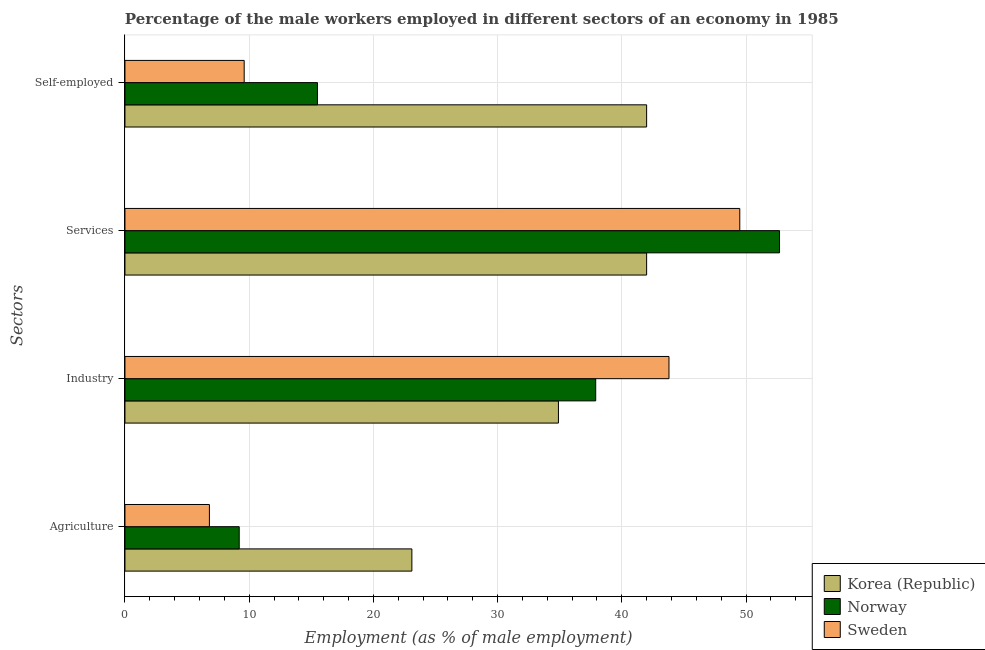What is the label of the 3rd group of bars from the top?
Provide a succinct answer. Industry. What is the percentage of male workers in agriculture in Norway?
Keep it short and to the point. 9.2. Across all countries, what is the maximum percentage of male workers in industry?
Give a very brief answer. 43.8. In which country was the percentage of self employed male workers maximum?
Provide a succinct answer. Korea (Republic). In which country was the percentage of male workers in industry minimum?
Your response must be concise. Korea (Republic). What is the total percentage of male workers in agriculture in the graph?
Your response must be concise. 39.1. What is the difference between the percentage of male workers in agriculture in Sweden and the percentage of male workers in services in Norway?
Ensure brevity in your answer.  -45.9. What is the average percentage of self employed male workers per country?
Give a very brief answer. 22.37. What is the difference between the percentage of male workers in agriculture and percentage of male workers in services in Korea (Republic)?
Offer a terse response. -18.9. In how many countries, is the percentage of self employed male workers greater than 48 %?
Offer a terse response. 0. What is the ratio of the percentage of self employed male workers in Korea (Republic) to that in Sweden?
Provide a short and direct response. 4.37. Is the percentage of male workers in industry in Korea (Republic) less than that in Norway?
Offer a terse response. Yes. Is the difference between the percentage of male workers in services in Korea (Republic) and Norway greater than the difference between the percentage of self employed male workers in Korea (Republic) and Norway?
Provide a succinct answer. No. What is the difference between the highest and the second highest percentage of self employed male workers?
Your response must be concise. 26.5. What is the difference between the highest and the lowest percentage of male workers in industry?
Keep it short and to the point. 8.9. What does the 3rd bar from the top in Self-employed represents?
Provide a short and direct response. Korea (Republic). Is it the case that in every country, the sum of the percentage of male workers in agriculture and percentage of male workers in industry is greater than the percentage of male workers in services?
Keep it short and to the point. No. Are all the bars in the graph horizontal?
Your answer should be compact. Yes. How many countries are there in the graph?
Your answer should be very brief. 3. What is the difference between two consecutive major ticks on the X-axis?
Provide a short and direct response. 10. Are the values on the major ticks of X-axis written in scientific E-notation?
Your answer should be very brief. No. Does the graph contain any zero values?
Give a very brief answer. No. Does the graph contain grids?
Make the answer very short. Yes. How are the legend labels stacked?
Make the answer very short. Vertical. What is the title of the graph?
Give a very brief answer. Percentage of the male workers employed in different sectors of an economy in 1985. What is the label or title of the X-axis?
Give a very brief answer. Employment (as % of male employment). What is the label or title of the Y-axis?
Provide a succinct answer. Sectors. What is the Employment (as % of male employment) of Korea (Republic) in Agriculture?
Make the answer very short. 23.1. What is the Employment (as % of male employment) of Norway in Agriculture?
Your answer should be very brief. 9.2. What is the Employment (as % of male employment) of Sweden in Agriculture?
Your answer should be compact. 6.8. What is the Employment (as % of male employment) of Korea (Republic) in Industry?
Your response must be concise. 34.9. What is the Employment (as % of male employment) in Norway in Industry?
Make the answer very short. 37.9. What is the Employment (as % of male employment) of Sweden in Industry?
Provide a succinct answer. 43.8. What is the Employment (as % of male employment) of Korea (Republic) in Services?
Offer a terse response. 42. What is the Employment (as % of male employment) of Norway in Services?
Provide a succinct answer. 52.7. What is the Employment (as % of male employment) of Sweden in Services?
Provide a short and direct response. 49.5. What is the Employment (as % of male employment) of Korea (Republic) in Self-employed?
Your answer should be very brief. 42. What is the Employment (as % of male employment) of Sweden in Self-employed?
Offer a very short reply. 9.6. Across all Sectors, what is the maximum Employment (as % of male employment) of Norway?
Your answer should be very brief. 52.7. Across all Sectors, what is the maximum Employment (as % of male employment) of Sweden?
Provide a short and direct response. 49.5. Across all Sectors, what is the minimum Employment (as % of male employment) of Korea (Republic)?
Your answer should be very brief. 23.1. Across all Sectors, what is the minimum Employment (as % of male employment) of Norway?
Give a very brief answer. 9.2. Across all Sectors, what is the minimum Employment (as % of male employment) in Sweden?
Your answer should be compact. 6.8. What is the total Employment (as % of male employment) of Korea (Republic) in the graph?
Offer a very short reply. 142. What is the total Employment (as % of male employment) in Norway in the graph?
Provide a short and direct response. 115.3. What is the total Employment (as % of male employment) of Sweden in the graph?
Your answer should be compact. 109.7. What is the difference between the Employment (as % of male employment) in Korea (Republic) in Agriculture and that in Industry?
Provide a succinct answer. -11.8. What is the difference between the Employment (as % of male employment) of Norway in Agriculture and that in Industry?
Your answer should be compact. -28.7. What is the difference between the Employment (as % of male employment) of Sweden in Agriculture and that in Industry?
Provide a short and direct response. -37. What is the difference between the Employment (as % of male employment) of Korea (Republic) in Agriculture and that in Services?
Provide a succinct answer. -18.9. What is the difference between the Employment (as % of male employment) of Norway in Agriculture and that in Services?
Your answer should be compact. -43.5. What is the difference between the Employment (as % of male employment) of Sweden in Agriculture and that in Services?
Your answer should be very brief. -42.7. What is the difference between the Employment (as % of male employment) of Korea (Republic) in Agriculture and that in Self-employed?
Give a very brief answer. -18.9. What is the difference between the Employment (as % of male employment) of Norway in Agriculture and that in Self-employed?
Ensure brevity in your answer.  -6.3. What is the difference between the Employment (as % of male employment) in Sweden in Agriculture and that in Self-employed?
Your answer should be very brief. -2.8. What is the difference between the Employment (as % of male employment) in Norway in Industry and that in Services?
Keep it short and to the point. -14.8. What is the difference between the Employment (as % of male employment) in Korea (Republic) in Industry and that in Self-employed?
Offer a very short reply. -7.1. What is the difference between the Employment (as % of male employment) in Norway in Industry and that in Self-employed?
Ensure brevity in your answer.  22.4. What is the difference between the Employment (as % of male employment) in Sweden in Industry and that in Self-employed?
Ensure brevity in your answer.  34.2. What is the difference between the Employment (as % of male employment) of Korea (Republic) in Services and that in Self-employed?
Offer a very short reply. 0. What is the difference between the Employment (as % of male employment) in Norway in Services and that in Self-employed?
Ensure brevity in your answer.  37.2. What is the difference between the Employment (as % of male employment) of Sweden in Services and that in Self-employed?
Make the answer very short. 39.9. What is the difference between the Employment (as % of male employment) of Korea (Republic) in Agriculture and the Employment (as % of male employment) of Norway in Industry?
Offer a very short reply. -14.8. What is the difference between the Employment (as % of male employment) in Korea (Republic) in Agriculture and the Employment (as % of male employment) in Sweden in Industry?
Give a very brief answer. -20.7. What is the difference between the Employment (as % of male employment) in Norway in Agriculture and the Employment (as % of male employment) in Sweden in Industry?
Give a very brief answer. -34.6. What is the difference between the Employment (as % of male employment) in Korea (Republic) in Agriculture and the Employment (as % of male employment) in Norway in Services?
Your response must be concise. -29.6. What is the difference between the Employment (as % of male employment) of Korea (Republic) in Agriculture and the Employment (as % of male employment) of Sweden in Services?
Offer a very short reply. -26.4. What is the difference between the Employment (as % of male employment) of Norway in Agriculture and the Employment (as % of male employment) of Sweden in Services?
Provide a short and direct response. -40.3. What is the difference between the Employment (as % of male employment) in Korea (Republic) in Agriculture and the Employment (as % of male employment) in Norway in Self-employed?
Give a very brief answer. 7.6. What is the difference between the Employment (as % of male employment) in Korea (Republic) in Agriculture and the Employment (as % of male employment) in Sweden in Self-employed?
Your response must be concise. 13.5. What is the difference between the Employment (as % of male employment) of Norway in Agriculture and the Employment (as % of male employment) of Sweden in Self-employed?
Ensure brevity in your answer.  -0.4. What is the difference between the Employment (as % of male employment) of Korea (Republic) in Industry and the Employment (as % of male employment) of Norway in Services?
Provide a succinct answer. -17.8. What is the difference between the Employment (as % of male employment) in Korea (Republic) in Industry and the Employment (as % of male employment) in Sweden in Services?
Provide a short and direct response. -14.6. What is the difference between the Employment (as % of male employment) of Norway in Industry and the Employment (as % of male employment) of Sweden in Services?
Offer a terse response. -11.6. What is the difference between the Employment (as % of male employment) of Korea (Republic) in Industry and the Employment (as % of male employment) of Norway in Self-employed?
Give a very brief answer. 19.4. What is the difference between the Employment (as % of male employment) of Korea (Republic) in Industry and the Employment (as % of male employment) of Sweden in Self-employed?
Your response must be concise. 25.3. What is the difference between the Employment (as % of male employment) in Norway in Industry and the Employment (as % of male employment) in Sweden in Self-employed?
Your answer should be compact. 28.3. What is the difference between the Employment (as % of male employment) of Korea (Republic) in Services and the Employment (as % of male employment) of Norway in Self-employed?
Give a very brief answer. 26.5. What is the difference between the Employment (as % of male employment) in Korea (Republic) in Services and the Employment (as % of male employment) in Sweden in Self-employed?
Provide a succinct answer. 32.4. What is the difference between the Employment (as % of male employment) of Norway in Services and the Employment (as % of male employment) of Sweden in Self-employed?
Your response must be concise. 43.1. What is the average Employment (as % of male employment) in Korea (Republic) per Sectors?
Provide a succinct answer. 35.5. What is the average Employment (as % of male employment) in Norway per Sectors?
Keep it short and to the point. 28.82. What is the average Employment (as % of male employment) of Sweden per Sectors?
Make the answer very short. 27.43. What is the difference between the Employment (as % of male employment) of Norway and Employment (as % of male employment) of Sweden in Agriculture?
Provide a succinct answer. 2.4. What is the difference between the Employment (as % of male employment) of Korea (Republic) and Employment (as % of male employment) of Sweden in Industry?
Make the answer very short. -8.9. What is the difference between the Employment (as % of male employment) in Korea (Republic) and Employment (as % of male employment) in Norway in Services?
Offer a very short reply. -10.7. What is the difference between the Employment (as % of male employment) in Korea (Republic) and Employment (as % of male employment) in Norway in Self-employed?
Give a very brief answer. 26.5. What is the difference between the Employment (as % of male employment) of Korea (Republic) and Employment (as % of male employment) of Sweden in Self-employed?
Provide a succinct answer. 32.4. What is the difference between the Employment (as % of male employment) of Norway and Employment (as % of male employment) of Sweden in Self-employed?
Your answer should be compact. 5.9. What is the ratio of the Employment (as % of male employment) in Korea (Republic) in Agriculture to that in Industry?
Offer a terse response. 0.66. What is the ratio of the Employment (as % of male employment) of Norway in Agriculture to that in Industry?
Provide a short and direct response. 0.24. What is the ratio of the Employment (as % of male employment) of Sweden in Agriculture to that in Industry?
Make the answer very short. 0.16. What is the ratio of the Employment (as % of male employment) of Korea (Republic) in Agriculture to that in Services?
Provide a short and direct response. 0.55. What is the ratio of the Employment (as % of male employment) in Norway in Agriculture to that in Services?
Your response must be concise. 0.17. What is the ratio of the Employment (as % of male employment) of Sweden in Agriculture to that in Services?
Offer a terse response. 0.14. What is the ratio of the Employment (as % of male employment) in Korea (Republic) in Agriculture to that in Self-employed?
Your answer should be very brief. 0.55. What is the ratio of the Employment (as % of male employment) in Norway in Agriculture to that in Self-employed?
Your response must be concise. 0.59. What is the ratio of the Employment (as % of male employment) in Sweden in Agriculture to that in Self-employed?
Keep it short and to the point. 0.71. What is the ratio of the Employment (as % of male employment) in Korea (Republic) in Industry to that in Services?
Offer a terse response. 0.83. What is the ratio of the Employment (as % of male employment) of Norway in Industry to that in Services?
Give a very brief answer. 0.72. What is the ratio of the Employment (as % of male employment) of Sweden in Industry to that in Services?
Your answer should be very brief. 0.88. What is the ratio of the Employment (as % of male employment) of Korea (Republic) in Industry to that in Self-employed?
Give a very brief answer. 0.83. What is the ratio of the Employment (as % of male employment) of Norway in Industry to that in Self-employed?
Ensure brevity in your answer.  2.45. What is the ratio of the Employment (as % of male employment) in Sweden in Industry to that in Self-employed?
Provide a short and direct response. 4.56. What is the ratio of the Employment (as % of male employment) in Korea (Republic) in Services to that in Self-employed?
Ensure brevity in your answer.  1. What is the ratio of the Employment (as % of male employment) of Sweden in Services to that in Self-employed?
Offer a terse response. 5.16. What is the difference between the highest and the second highest Employment (as % of male employment) of Korea (Republic)?
Ensure brevity in your answer.  0. What is the difference between the highest and the second highest Employment (as % of male employment) of Norway?
Ensure brevity in your answer.  14.8. What is the difference between the highest and the second highest Employment (as % of male employment) of Sweden?
Give a very brief answer. 5.7. What is the difference between the highest and the lowest Employment (as % of male employment) of Norway?
Your answer should be very brief. 43.5. What is the difference between the highest and the lowest Employment (as % of male employment) in Sweden?
Offer a terse response. 42.7. 